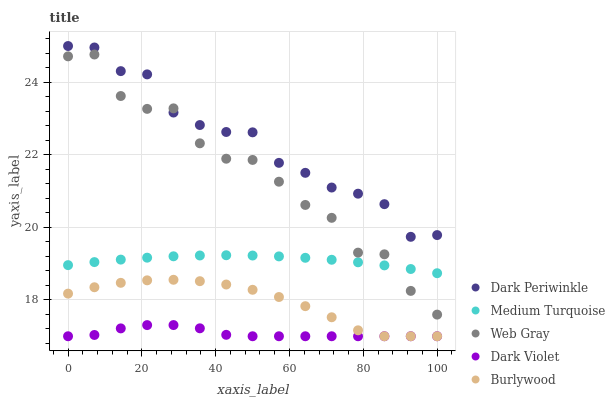Does Dark Violet have the minimum area under the curve?
Answer yes or no. Yes. Does Dark Periwinkle have the maximum area under the curve?
Answer yes or no. Yes. Does Web Gray have the minimum area under the curve?
Answer yes or no. No. Does Web Gray have the maximum area under the curve?
Answer yes or no. No. Is Medium Turquoise the smoothest?
Answer yes or no. Yes. Is Web Gray the roughest?
Answer yes or no. Yes. Is Dark Violet the smoothest?
Answer yes or no. No. Is Dark Violet the roughest?
Answer yes or no. No. Does Burlywood have the lowest value?
Answer yes or no. Yes. Does Web Gray have the lowest value?
Answer yes or no. No. Does Dark Periwinkle have the highest value?
Answer yes or no. Yes. Does Web Gray have the highest value?
Answer yes or no. No. Is Burlywood less than Medium Turquoise?
Answer yes or no. Yes. Is Web Gray greater than Dark Violet?
Answer yes or no. Yes. Does Dark Periwinkle intersect Web Gray?
Answer yes or no. Yes. Is Dark Periwinkle less than Web Gray?
Answer yes or no. No. Is Dark Periwinkle greater than Web Gray?
Answer yes or no. No. Does Burlywood intersect Medium Turquoise?
Answer yes or no. No. 